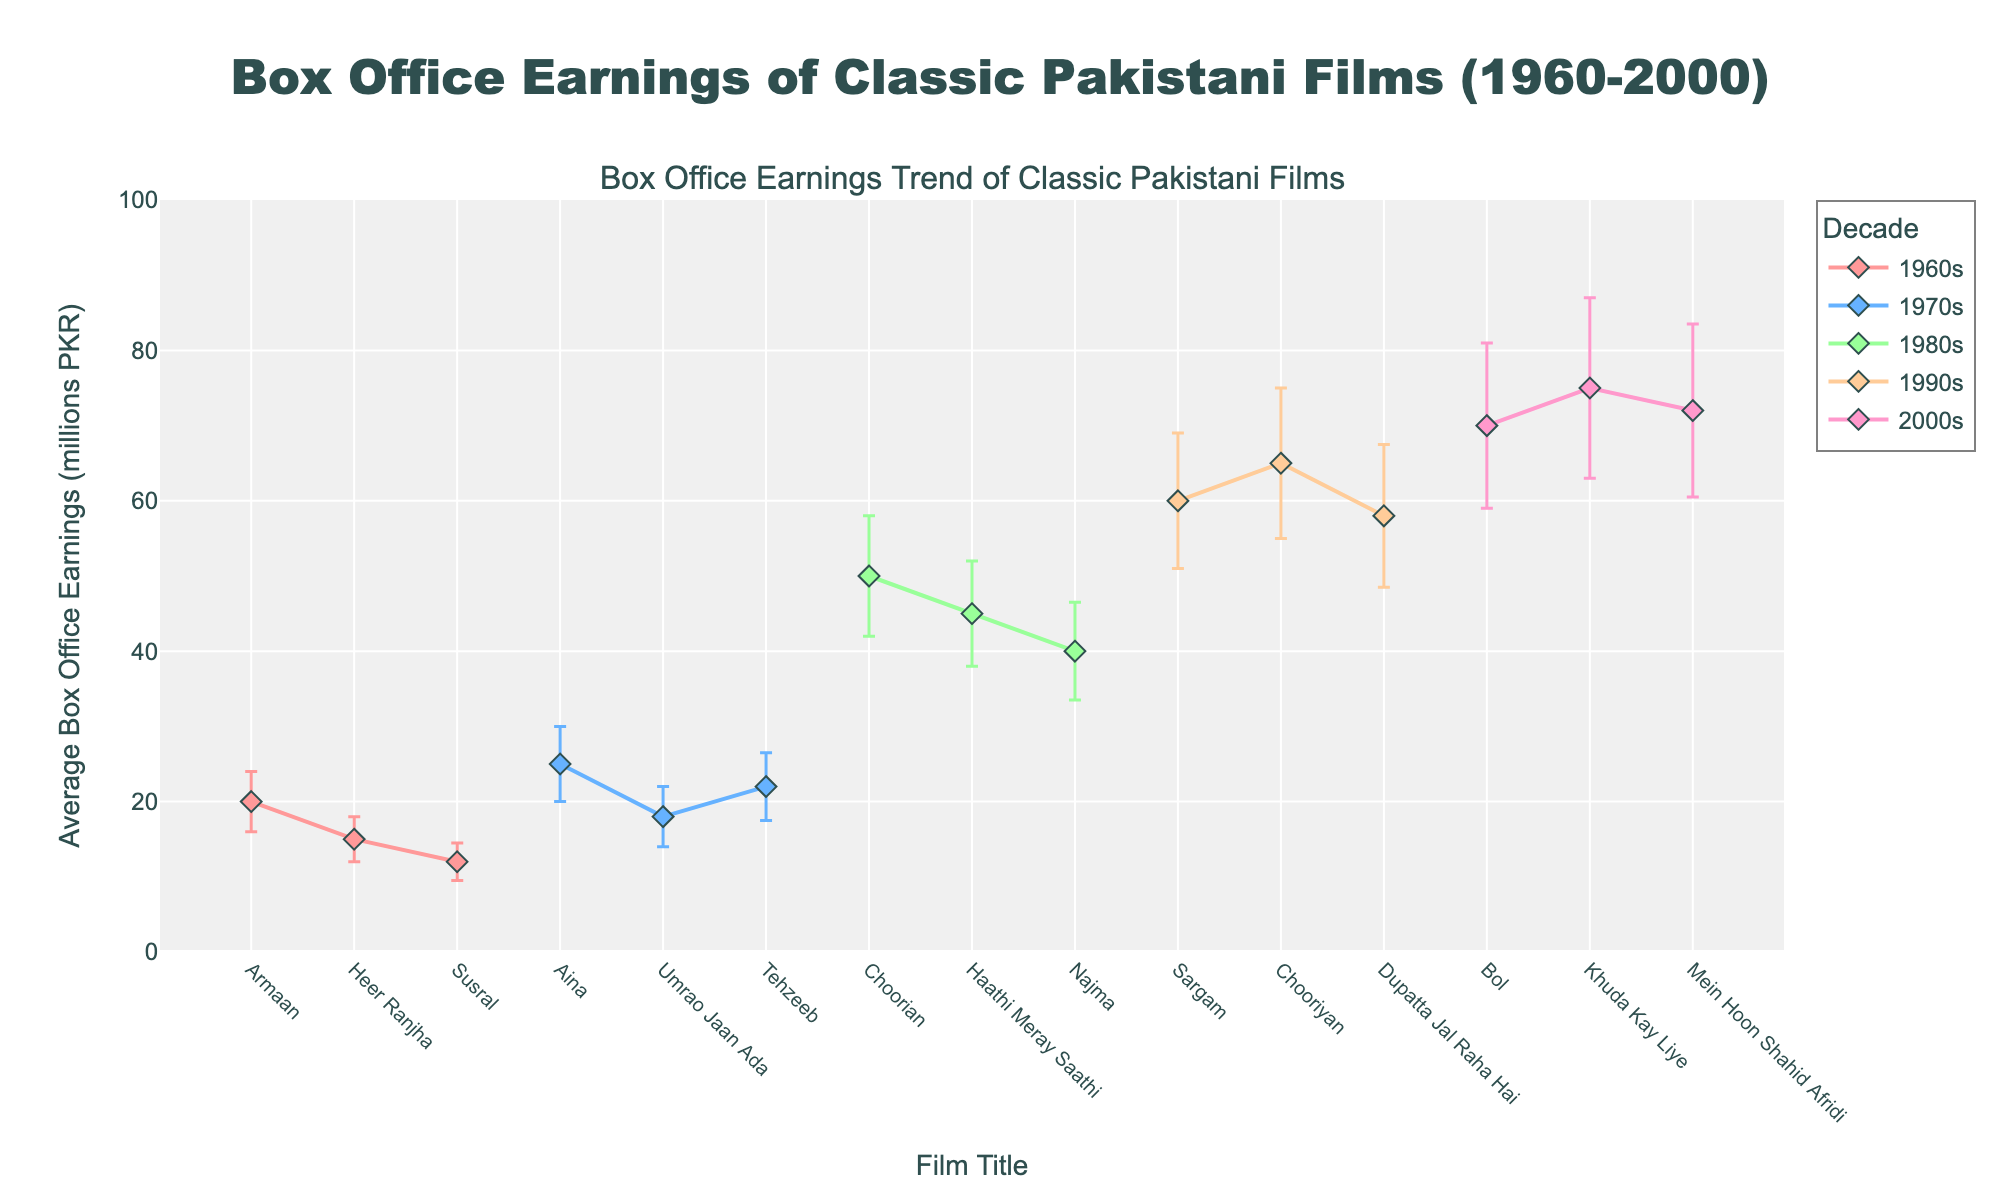Which decade shows the highest average box office earnings? The 2000s have the most significant peak in average box office earnings among the listed films, with the movies "Khuda Kay Liye" (75 million PKR), "Bol" (70 million PKR), and "Mein Hoon Shahid Afridi" (72 million PKR).
Answer: The 2000s What is the range of box office earnings for films in the 1980s? The lowest box office earnings in the 1980s is for the film "Najma" with 40 million PKR, while the highest is "Choorian" with 50 million PKR. Therefore, the range is 50 - 40 million PKR.
Answer: 10 million PKR How does the box office performance of "Aina" compare to other films in the 1970s? "Aina" has the highest average box office earnings in the 1970s (25 million PKR), followed by "Tehzeeb" (22 million PKR) and "Umrao Jaan Ada" (18 million PKR).
Answer: "Aina" has the highest earnings Which film has the highest standard deviation in earnings, indicating the most variability? "Khuda Kay Liye" in the 2000s has the highest standard deviation of 12 million PKR, showing the most variability in its box office earnings.
Answer: "Khuda Kay Liye" What is the primary color used for the error bars representing the 1960s films? The error bars for the 1960s films are primarily shown in a shade of light red.
Answer: Light red Compare the box office earnings of "Choorian" from the 1980s to "Chooriyan" from the 1990s. "Choorian" from the 1980s has average earnings of 50 million PKR, while "Chooriyan" from the 1990s has higher average earnings at 65 million PKR.
Answer: "Chooriyan" from the 1990s has higher earnings For which decade do the films exhibit the least variability in box office earnings? The 1960s films have the least variability, with standard deviations ranging from 2.5 million PKR to 4 million PKR.
Answer: The 1960s Which decade has the most films represented in the plot? Both the 1980s and the 2000s have three films each, but the 1990s also has three films, making it the decade with the most films represented.
Answer: The 1980s, 1990s, and 2000s 